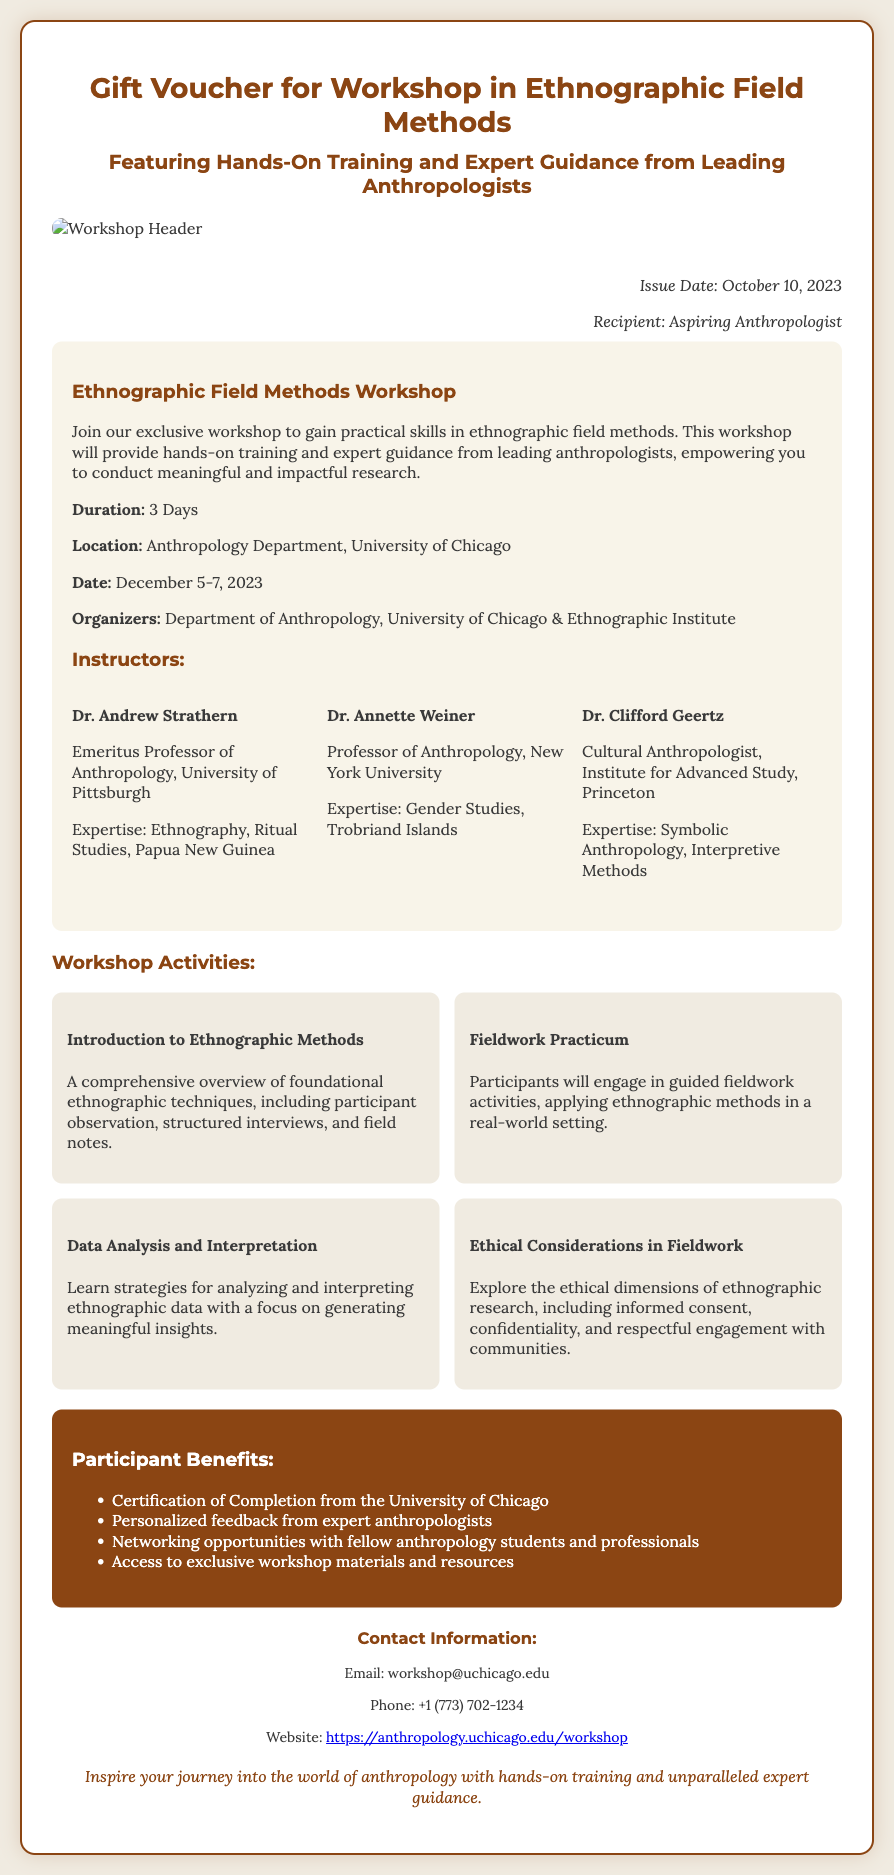What is the title of the workshop? The title of the workshop is mentioned clearly under the workshop details section.
Answer: Ethnographic Field Methods Workshop Who is the recipient of the gift voucher? The recipient's name is provided in the document, specifically in the section where the issue is mentioned.
Answer: Aspiring Anthropologist When does the workshop take place? The dates for the workshop are explicitly stated in the document under the workshop details.
Answer: December 5-7, 2023 How many days is the workshop? The duration of the workshop is specified in a sentence in the workshop details.
Answer: 3 Days Who is one of the instructors? The document lists several instructors, and this question asks for just one name from the instructors' section.
Answer: Dr. Andrew Strathern What is one of the workshop activities? The activities conducted during the workshop are outlined clearly, allowing for the selection of one activity.
Answer: Fieldwork Practicum What certification will participants receive? The benefits section of the document includes information on what participants will receive upon completion.
Answer: Certification of Completion from the University of Chicago What is the contact email for the workshop? The contact information section provides an email address for inquiries related to the workshop.
Answer: workshop@uchicago.edu What is the background color of the voucher? The visual design details of the voucher document indicate the color scheme utilized throughout.
Answer: #f0ebe1 